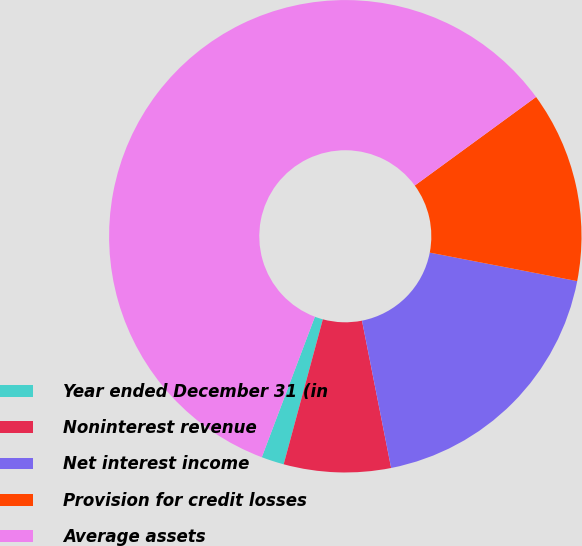Convert chart. <chart><loc_0><loc_0><loc_500><loc_500><pie_chart><fcel>Year ended December 31 (in<fcel>Noninterest revenue<fcel>Net interest income<fcel>Provision for credit losses<fcel>Average assets<nl><fcel>1.55%<fcel>7.31%<fcel>18.85%<fcel>13.08%<fcel>59.21%<nl></chart> 